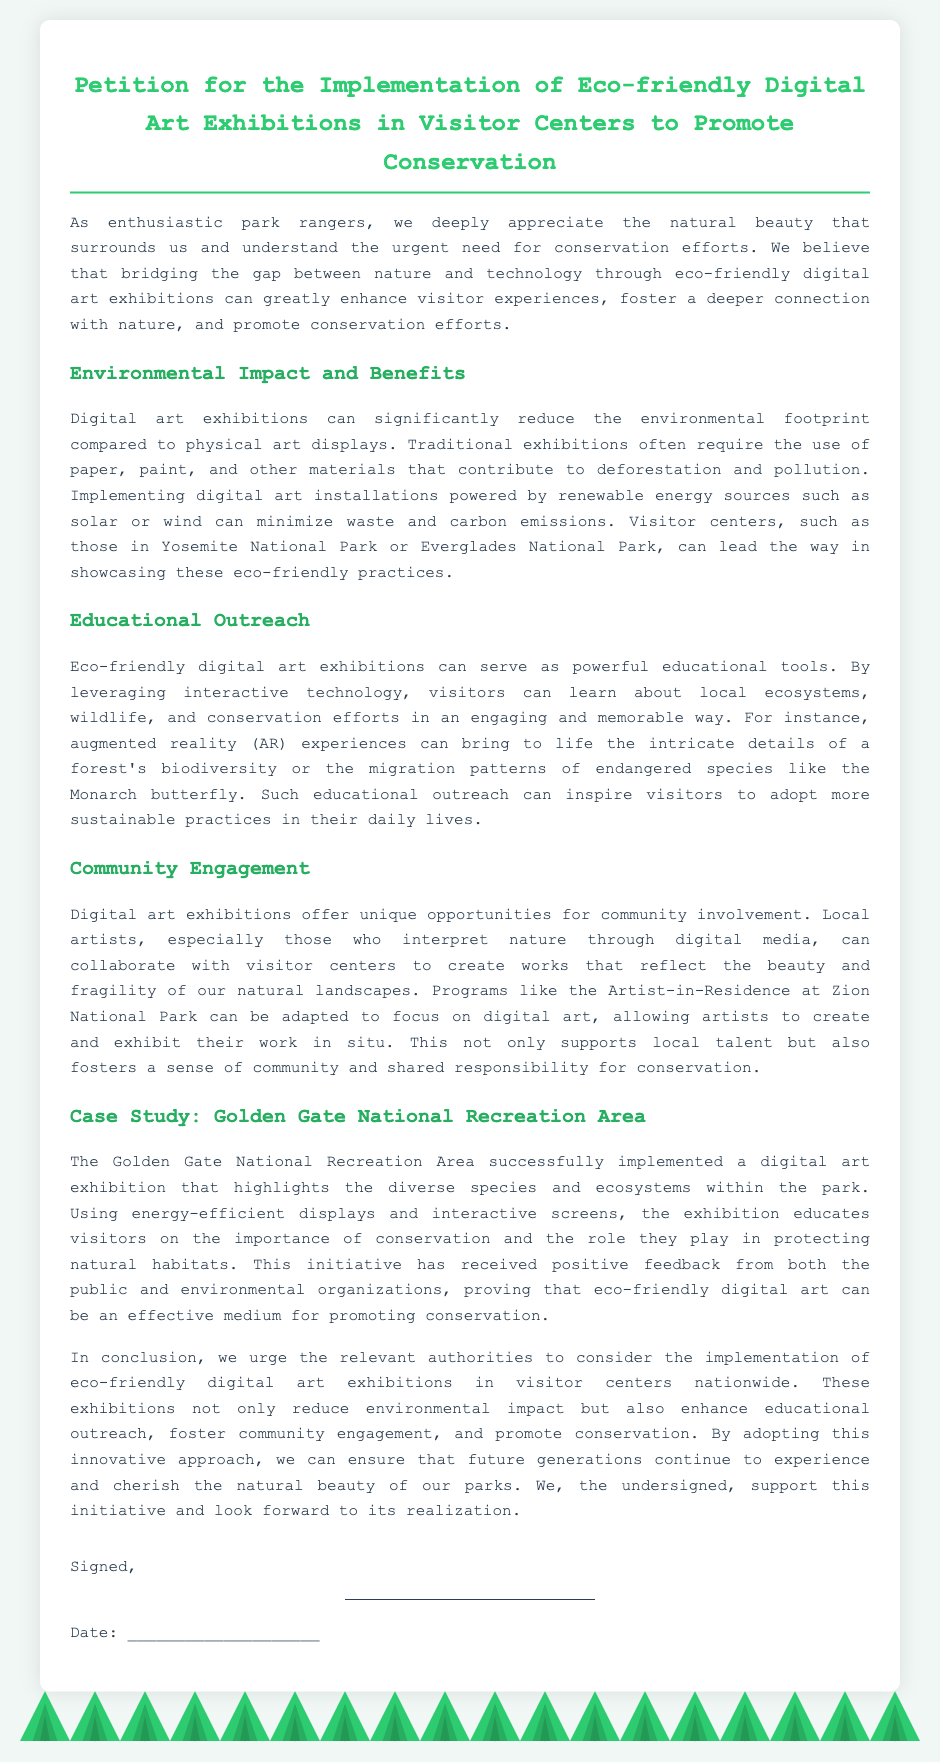what is the title of the petition? The title is prominently displayed at the top of the document to indicate the topic and purpose of the petition.
Answer: Petition for the Implementation of Eco-friendly Digital Art Exhibitions in Visitor Centers to Promote Conservation what is one benefit of digital art exhibitions mentioned in the document? The document outlines multiple benefits, highlighting that digital art can notably reduce environmental footprints.
Answer: Reduce environmental footprint which park is cited as an example of implementing digital art exhibitions? The document mentions a specific case study highlighting a successful implementation of digital art exhibitions.
Answer: Golden Gate National Recreation Area what technology is suggested for educational outreach? The document identifies a specific interactive technology that enhances learning and engagement regarding local ecosystems.
Answer: Augmented reality what is a proposed collaboration mentioned for community engagement? The document discusses how local artists can work with visitor centers to create meaningful works of art.
Answer: Collaborate with visitor centers how do eco-friendly digital art exhibitions minimize waste? The document provides clear reasoning about how digital art reduces reliance on traditional materials, thereby minimizing waste.
Answer: Powered by renewable energy sources who receives the petition upon signing? The closing part of the document indicates who the petition is aimed at for considering the initiative.
Answer: Relevant authorities what type of installations are suggested to power the digital art? The document specifies the kind of energy sources that could be utilized for the exhibitions.
Answer: Renewable energy sources 